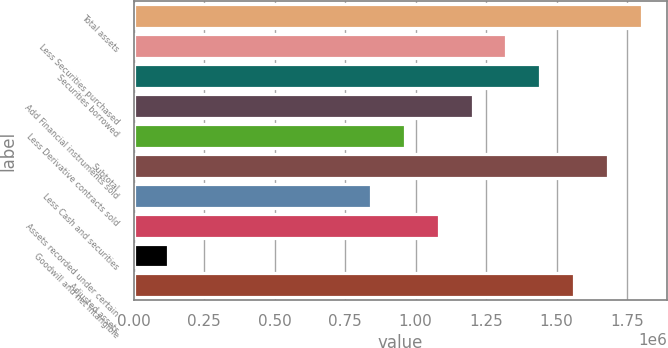Convert chart to OTSL. <chart><loc_0><loc_0><loc_500><loc_500><bar_chart><fcel>Total assets<fcel>Less Securities purchased<fcel>Securities borrowed<fcel>Add Financial instruments sold<fcel>Less Derivative contracts sold<fcel>Subtotal<fcel>Less Cash and securities<fcel>Assets recorded under certain<fcel>Goodwill and net intangible<fcel>Adjusted assets<nl><fcel>1.80255e+06<fcel>1.32216e+06<fcel>1.44226e+06<fcel>1.20206e+06<fcel>961872<fcel>1.68245e+06<fcel>841776<fcel>1.08197e+06<fcel>121196<fcel>1.56235e+06<nl></chart> 